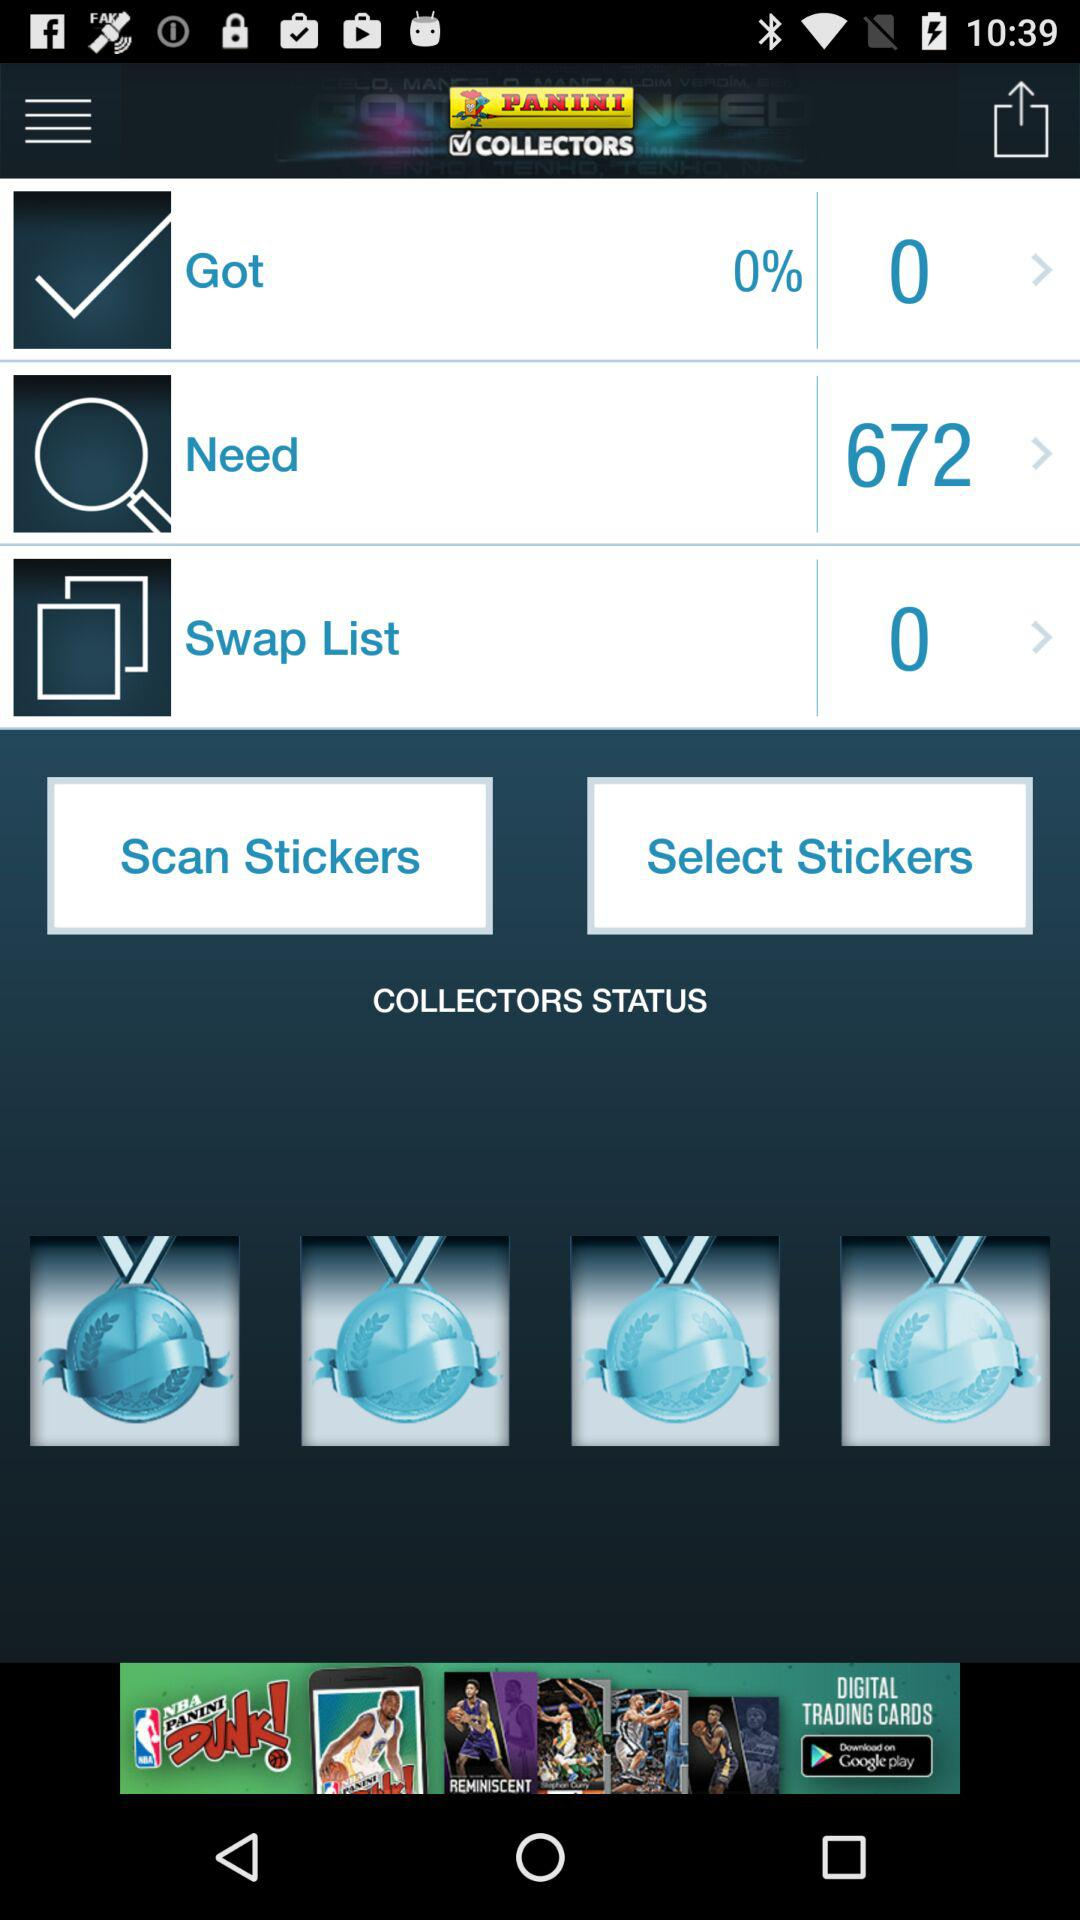What is the number of needs shown in the application? The number of needs shown in the application is 672. 